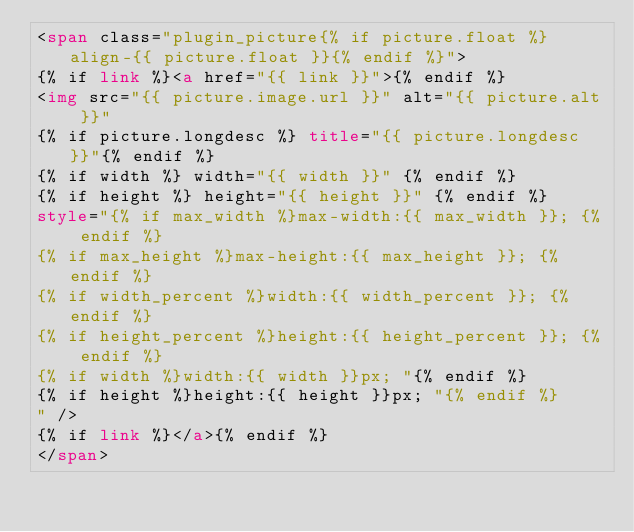<code> <loc_0><loc_0><loc_500><loc_500><_HTML_><span class="plugin_picture{% if picture.float %} align-{{ picture.float }}{% endif %}">
{% if link %}<a href="{{ link }}">{% endif %}
<img src="{{ picture.image.url }}" alt="{{ picture.alt }}"
{% if picture.longdesc %} title="{{ picture.longdesc }}"{% endif %}
{% if width %} width="{{ width }}" {% endif %}
{% if height %} height="{{ height }}" {% endif %}
style="{% if max_width %}max-width:{{ max_width }}; {% endif %}
{% if max_height %}max-height:{{ max_height }}; {% endif %}
{% if width_percent %}width:{{ width_percent }}; {% endif %}
{% if height_percent %}height:{{ height_percent }}; {% endif %}
{% if width %}width:{{ width }}px; "{% endif %}
{% if height %}height:{{ height }}px; "{% endif %}
" />
{% if link %}</a>{% endif %}
</span>
</code> 